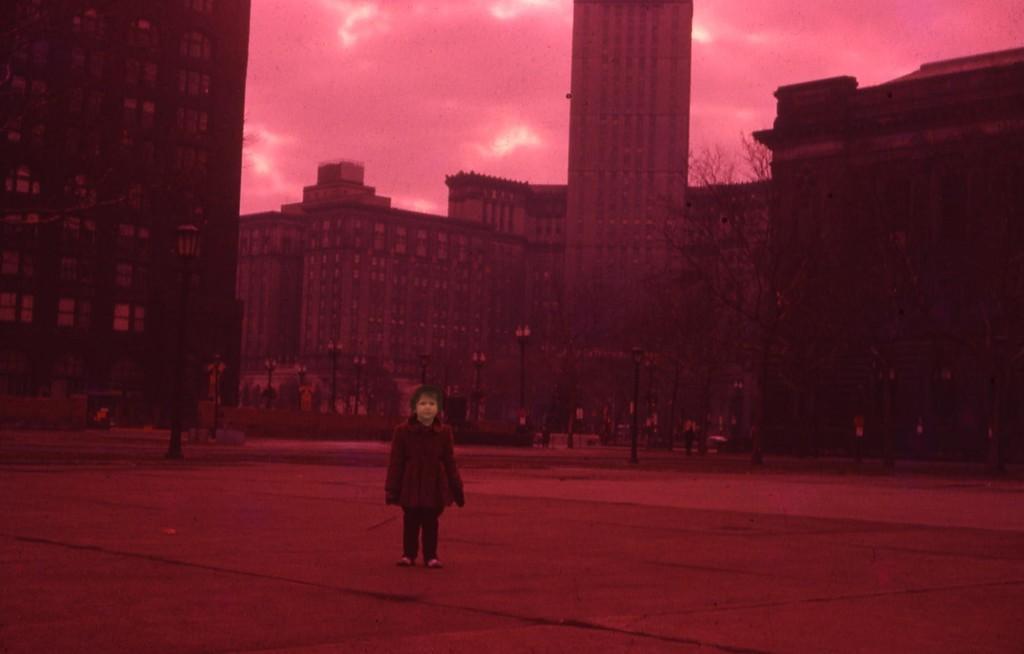Describe this image in one or two sentences. In this edited image there is a girl standing on the road. Behind her there are buildings, trees and street light poles. At the top there is the sky. 